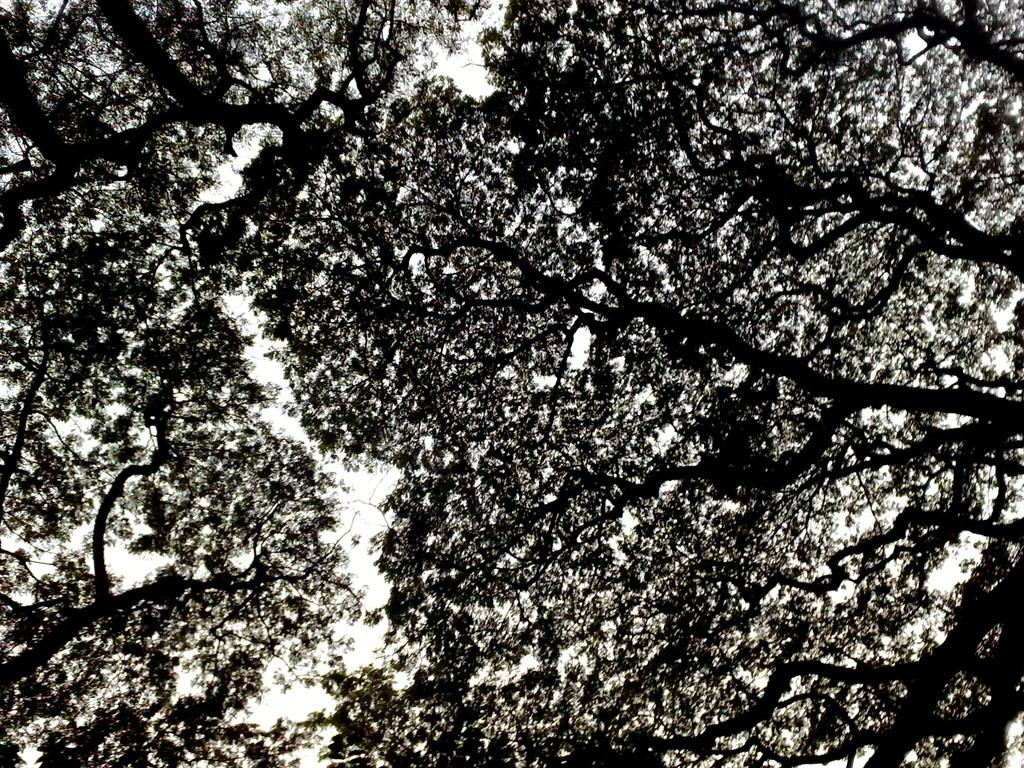What type of vegetation can be seen in the image? There are trees in the image. What part of the natural environment is visible in the image? The sky is visible in the image. How many glass balls are hanging from the trees in the image? There are no glass balls present in the image; it only features trees and the sky. Can you see any fingers in the image? There are no fingers visible in the image. 